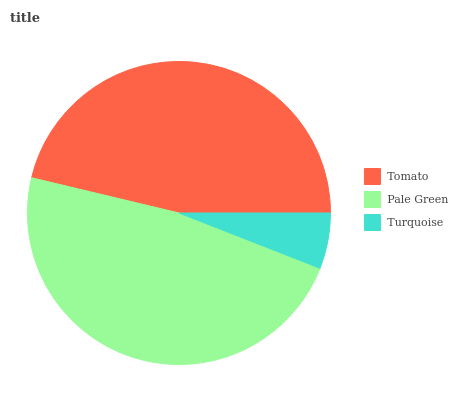Is Turquoise the minimum?
Answer yes or no. Yes. Is Pale Green the maximum?
Answer yes or no. Yes. Is Pale Green the minimum?
Answer yes or no. No. Is Turquoise the maximum?
Answer yes or no. No. Is Pale Green greater than Turquoise?
Answer yes or no. Yes. Is Turquoise less than Pale Green?
Answer yes or no. Yes. Is Turquoise greater than Pale Green?
Answer yes or no. No. Is Pale Green less than Turquoise?
Answer yes or no. No. Is Tomato the high median?
Answer yes or no. Yes. Is Tomato the low median?
Answer yes or no. Yes. Is Pale Green the high median?
Answer yes or no. No. Is Turquoise the low median?
Answer yes or no. No. 